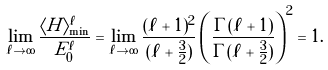Convert formula to latex. <formula><loc_0><loc_0><loc_500><loc_500>\lim _ { \ell \to \infty } \frac { \langle H \rangle ^ { \ell } _ { \min } } { E ^ { \ell } _ { 0 } } = \lim _ { \ell \to \infty } \frac { ( \ell + 1 ) ^ { 2 } } { ( \ell + \frac { 3 } { 2 } ) } \left ( \frac { \Gamma ( \ell + 1 ) } { \Gamma ( \ell + \frac { 3 } { 2 } ) } \right ) ^ { 2 } = 1 .</formula> 